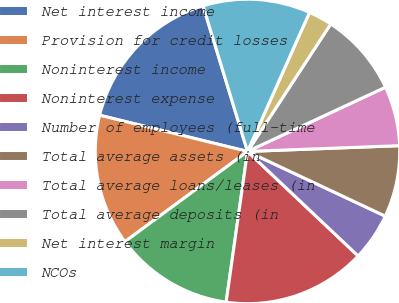Convert chart to OTSL. <chart><loc_0><loc_0><loc_500><loc_500><pie_chart><fcel>Net interest income<fcel>Provision for credit losses<fcel>Noninterest income<fcel>Noninterest expense<fcel>Number of employees (full-time<fcel>Total average assets (in<fcel>Total average loans/leases (in<fcel>Total average deposits (in<fcel>Net interest margin<fcel>NCOs<nl><fcel>16.46%<fcel>13.92%<fcel>12.66%<fcel>15.19%<fcel>5.06%<fcel>7.59%<fcel>6.33%<fcel>8.86%<fcel>2.53%<fcel>11.39%<nl></chart> 